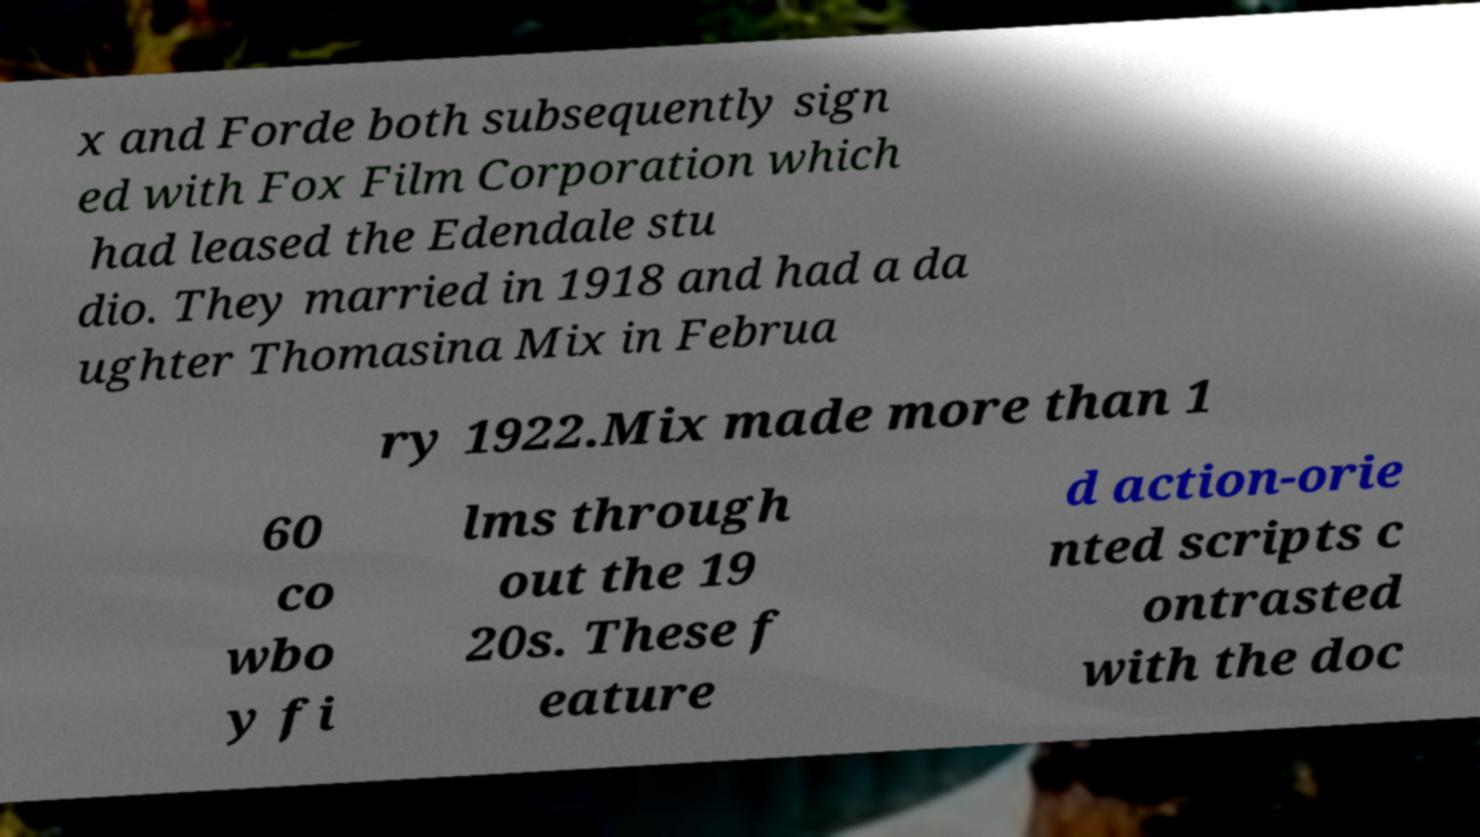Could you extract and type out the text from this image? x and Forde both subsequently sign ed with Fox Film Corporation which had leased the Edendale stu dio. They married in 1918 and had a da ughter Thomasina Mix in Februa ry 1922.Mix made more than 1 60 co wbo y fi lms through out the 19 20s. These f eature d action-orie nted scripts c ontrasted with the doc 